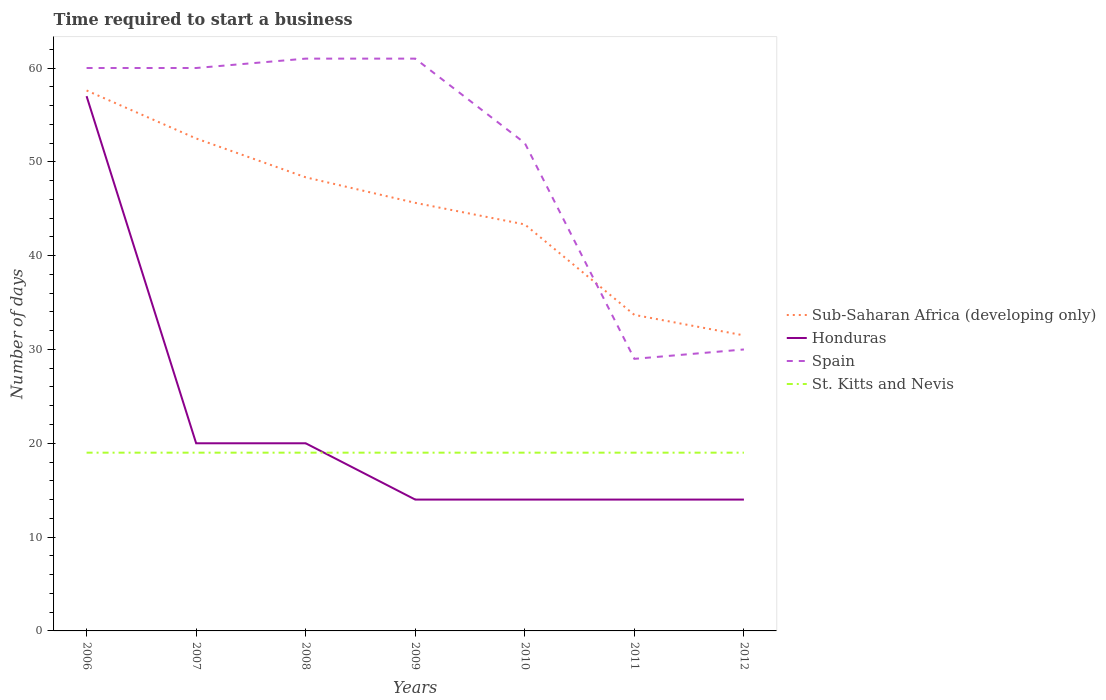How many different coloured lines are there?
Offer a terse response. 4. Does the line corresponding to Sub-Saharan Africa (developing only) intersect with the line corresponding to St. Kitts and Nevis?
Keep it short and to the point. No. Is the number of lines equal to the number of legend labels?
Your answer should be very brief. Yes. Across all years, what is the maximum number of days required to start a business in Sub-Saharan Africa (developing only)?
Offer a very short reply. 31.5. What is the total number of days required to start a business in St. Kitts and Nevis in the graph?
Give a very brief answer. 0. What is the difference between the highest and the second highest number of days required to start a business in Honduras?
Offer a terse response. 43. Is the number of days required to start a business in Sub-Saharan Africa (developing only) strictly greater than the number of days required to start a business in St. Kitts and Nevis over the years?
Ensure brevity in your answer.  No. How many lines are there?
Provide a succinct answer. 4. How many years are there in the graph?
Provide a succinct answer. 7. Are the values on the major ticks of Y-axis written in scientific E-notation?
Offer a terse response. No. Does the graph contain grids?
Your answer should be very brief. No. Where does the legend appear in the graph?
Your answer should be very brief. Center right. How many legend labels are there?
Your response must be concise. 4. What is the title of the graph?
Provide a short and direct response. Time required to start a business. What is the label or title of the Y-axis?
Give a very brief answer. Number of days. What is the Number of days in Sub-Saharan Africa (developing only) in 2006?
Your response must be concise. 57.6. What is the Number of days of Honduras in 2006?
Provide a succinct answer. 57. What is the Number of days in Spain in 2006?
Offer a very short reply. 60. What is the Number of days of Sub-Saharan Africa (developing only) in 2007?
Keep it short and to the point. 52.49. What is the Number of days in Honduras in 2007?
Your answer should be very brief. 20. What is the Number of days of Spain in 2007?
Your answer should be very brief. 60. What is the Number of days in Sub-Saharan Africa (developing only) in 2008?
Your answer should be compact. 48.35. What is the Number of days in Honduras in 2008?
Give a very brief answer. 20. What is the Number of days of St. Kitts and Nevis in 2008?
Ensure brevity in your answer.  19. What is the Number of days in Sub-Saharan Africa (developing only) in 2009?
Offer a terse response. 45.63. What is the Number of days in Honduras in 2009?
Offer a very short reply. 14. What is the Number of days of St. Kitts and Nevis in 2009?
Your response must be concise. 19. What is the Number of days in Sub-Saharan Africa (developing only) in 2010?
Provide a succinct answer. 43.33. What is the Number of days in Honduras in 2010?
Offer a terse response. 14. What is the Number of days of St. Kitts and Nevis in 2010?
Provide a succinct answer. 19. What is the Number of days of Sub-Saharan Africa (developing only) in 2011?
Keep it short and to the point. 33.69. What is the Number of days in Spain in 2011?
Keep it short and to the point. 29. What is the Number of days in Sub-Saharan Africa (developing only) in 2012?
Give a very brief answer. 31.5. What is the Number of days in Honduras in 2012?
Keep it short and to the point. 14. What is the Number of days of St. Kitts and Nevis in 2012?
Your answer should be very brief. 19. Across all years, what is the maximum Number of days in Sub-Saharan Africa (developing only)?
Your answer should be very brief. 57.6. Across all years, what is the maximum Number of days of Honduras?
Keep it short and to the point. 57. Across all years, what is the maximum Number of days of Spain?
Offer a very short reply. 61. Across all years, what is the maximum Number of days in St. Kitts and Nevis?
Your answer should be very brief. 19. Across all years, what is the minimum Number of days of Sub-Saharan Africa (developing only)?
Provide a short and direct response. 31.5. What is the total Number of days in Sub-Saharan Africa (developing only) in the graph?
Offer a terse response. 312.58. What is the total Number of days in Honduras in the graph?
Provide a succinct answer. 153. What is the total Number of days of Spain in the graph?
Offer a very short reply. 353. What is the total Number of days of St. Kitts and Nevis in the graph?
Give a very brief answer. 133. What is the difference between the Number of days in Sub-Saharan Africa (developing only) in 2006 and that in 2007?
Keep it short and to the point. 5.12. What is the difference between the Number of days of Sub-Saharan Africa (developing only) in 2006 and that in 2008?
Provide a short and direct response. 9.26. What is the difference between the Number of days of St. Kitts and Nevis in 2006 and that in 2008?
Provide a succinct answer. 0. What is the difference between the Number of days in Sub-Saharan Africa (developing only) in 2006 and that in 2009?
Your answer should be compact. 11.98. What is the difference between the Number of days in Honduras in 2006 and that in 2009?
Your answer should be compact. 43. What is the difference between the Number of days in Spain in 2006 and that in 2009?
Offer a very short reply. -1. What is the difference between the Number of days in St. Kitts and Nevis in 2006 and that in 2009?
Provide a short and direct response. 0. What is the difference between the Number of days in Sub-Saharan Africa (developing only) in 2006 and that in 2010?
Provide a succinct answer. 14.28. What is the difference between the Number of days in Honduras in 2006 and that in 2010?
Make the answer very short. 43. What is the difference between the Number of days of St. Kitts and Nevis in 2006 and that in 2010?
Your answer should be compact. 0. What is the difference between the Number of days in Sub-Saharan Africa (developing only) in 2006 and that in 2011?
Keep it short and to the point. 23.92. What is the difference between the Number of days in Spain in 2006 and that in 2011?
Provide a short and direct response. 31. What is the difference between the Number of days in Sub-Saharan Africa (developing only) in 2006 and that in 2012?
Offer a very short reply. 26.1. What is the difference between the Number of days of Honduras in 2006 and that in 2012?
Your answer should be compact. 43. What is the difference between the Number of days of Sub-Saharan Africa (developing only) in 2007 and that in 2008?
Give a very brief answer. 4.14. What is the difference between the Number of days in Sub-Saharan Africa (developing only) in 2007 and that in 2009?
Provide a short and direct response. 6.86. What is the difference between the Number of days of Honduras in 2007 and that in 2009?
Offer a terse response. 6. What is the difference between the Number of days in St. Kitts and Nevis in 2007 and that in 2009?
Keep it short and to the point. 0. What is the difference between the Number of days of Sub-Saharan Africa (developing only) in 2007 and that in 2010?
Your answer should be compact. 9.16. What is the difference between the Number of days of Honduras in 2007 and that in 2010?
Keep it short and to the point. 6. What is the difference between the Number of days of Spain in 2007 and that in 2010?
Offer a terse response. 8. What is the difference between the Number of days of Sub-Saharan Africa (developing only) in 2007 and that in 2011?
Give a very brief answer. 18.8. What is the difference between the Number of days of Sub-Saharan Africa (developing only) in 2007 and that in 2012?
Make the answer very short. 20.99. What is the difference between the Number of days in Honduras in 2007 and that in 2012?
Provide a short and direct response. 6. What is the difference between the Number of days in Sub-Saharan Africa (developing only) in 2008 and that in 2009?
Keep it short and to the point. 2.72. What is the difference between the Number of days of Spain in 2008 and that in 2009?
Offer a very short reply. 0. What is the difference between the Number of days in Sub-Saharan Africa (developing only) in 2008 and that in 2010?
Offer a terse response. 5.02. What is the difference between the Number of days of Honduras in 2008 and that in 2010?
Give a very brief answer. 6. What is the difference between the Number of days in St. Kitts and Nevis in 2008 and that in 2010?
Provide a succinct answer. 0. What is the difference between the Number of days of Sub-Saharan Africa (developing only) in 2008 and that in 2011?
Make the answer very short. 14.66. What is the difference between the Number of days of St. Kitts and Nevis in 2008 and that in 2011?
Make the answer very short. 0. What is the difference between the Number of days of Sub-Saharan Africa (developing only) in 2008 and that in 2012?
Ensure brevity in your answer.  16.85. What is the difference between the Number of days in St. Kitts and Nevis in 2008 and that in 2012?
Your answer should be compact. 0. What is the difference between the Number of days of Sub-Saharan Africa (developing only) in 2009 and that in 2010?
Provide a succinct answer. 2.3. What is the difference between the Number of days of Honduras in 2009 and that in 2010?
Offer a terse response. 0. What is the difference between the Number of days of Spain in 2009 and that in 2010?
Offer a terse response. 9. What is the difference between the Number of days in Sub-Saharan Africa (developing only) in 2009 and that in 2011?
Offer a terse response. 11.94. What is the difference between the Number of days of Honduras in 2009 and that in 2011?
Provide a short and direct response. 0. What is the difference between the Number of days in Spain in 2009 and that in 2011?
Your response must be concise. 32. What is the difference between the Number of days in Sub-Saharan Africa (developing only) in 2009 and that in 2012?
Make the answer very short. 14.13. What is the difference between the Number of days in Honduras in 2009 and that in 2012?
Your answer should be compact. 0. What is the difference between the Number of days in St. Kitts and Nevis in 2009 and that in 2012?
Provide a short and direct response. 0. What is the difference between the Number of days of Sub-Saharan Africa (developing only) in 2010 and that in 2011?
Your answer should be very brief. 9.64. What is the difference between the Number of days of Honduras in 2010 and that in 2011?
Give a very brief answer. 0. What is the difference between the Number of days of St. Kitts and Nevis in 2010 and that in 2011?
Ensure brevity in your answer.  0. What is the difference between the Number of days of Sub-Saharan Africa (developing only) in 2010 and that in 2012?
Provide a succinct answer. 11.83. What is the difference between the Number of days in Honduras in 2010 and that in 2012?
Your response must be concise. 0. What is the difference between the Number of days of St. Kitts and Nevis in 2010 and that in 2012?
Your response must be concise. 0. What is the difference between the Number of days of Sub-Saharan Africa (developing only) in 2011 and that in 2012?
Your response must be concise. 2.19. What is the difference between the Number of days of St. Kitts and Nevis in 2011 and that in 2012?
Offer a terse response. 0. What is the difference between the Number of days of Sub-Saharan Africa (developing only) in 2006 and the Number of days of Honduras in 2007?
Provide a succinct answer. 37.6. What is the difference between the Number of days of Sub-Saharan Africa (developing only) in 2006 and the Number of days of Spain in 2007?
Offer a terse response. -2.4. What is the difference between the Number of days in Sub-Saharan Africa (developing only) in 2006 and the Number of days in St. Kitts and Nevis in 2007?
Keep it short and to the point. 38.6. What is the difference between the Number of days of Honduras in 2006 and the Number of days of St. Kitts and Nevis in 2007?
Keep it short and to the point. 38. What is the difference between the Number of days of Spain in 2006 and the Number of days of St. Kitts and Nevis in 2007?
Provide a short and direct response. 41. What is the difference between the Number of days of Sub-Saharan Africa (developing only) in 2006 and the Number of days of Honduras in 2008?
Offer a very short reply. 37.6. What is the difference between the Number of days in Sub-Saharan Africa (developing only) in 2006 and the Number of days in Spain in 2008?
Provide a short and direct response. -3.4. What is the difference between the Number of days in Sub-Saharan Africa (developing only) in 2006 and the Number of days in St. Kitts and Nevis in 2008?
Provide a short and direct response. 38.6. What is the difference between the Number of days of Sub-Saharan Africa (developing only) in 2006 and the Number of days of Honduras in 2009?
Your answer should be very brief. 43.6. What is the difference between the Number of days of Sub-Saharan Africa (developing only) in 2006 and the Number of days of Spain in 2009?
Your response must be concise. -3.4. What is the difference between the Number of days in Sub-Saharan Africa (developing only) in 2006 and the Number of days in St. Kitts and Nevis in 2009?
Give a very brief answer. 38.6. What is the difference between the Number of days in Spain in 2006 and the Number of days in St. Kitts and Nevis in 2009?
Ensure brevity in your answer.  41. What is the difference between the Number of days in Sub-Saharan Africa (developing only) in 2006 and the Number of days in Honduras in 2010?
Make the answer very short. 43.6. What is the difference between the Number of days of Sub-Saharan Africa (developing only) in 2006 and the Number of days of Spain in 2010?
Your answer should be very brief. 5.6. What is the difference between the Number of days of Sub-Saharan Africa (developing only) in 2006 and the Number of days of St. Kitts and Nevis in 2010?
Offer a very short reply. 38.6. What is the difference between the Number of days in Honduras in 2006 and the Number of days in Spain in 2010?
Give a very brief answer. 5. What is the difference between the Number of days in Spain in 2006 and the Number of days in St. Kitts and Nevis in 2010?
Give a very brief answer. 41. What is the difference between the Number of days in Sub-Saharan Africa (developing only) in 2006 and the Number of days in Honduras in 2011?
Ensure brevity in your answer.  43.6. What is the difference between the Number of days of Sub-Saharan Africa (developing only) in 2006 and the Number of days of Spain in 2011?
Your answer should be compact. 28.6. What is the difference between the Number of days in Sub-Saharan Africa (developing only) in 2006 and the Number of days in St. Kitts and Nevis in 2011?
Your response must be concise. 38.6. What is the difference between the Number of days of Spain in 2006 and the Number of days of St. Kitts and Nevis in 2011?
Keep it short and to the point. 41. What is the difference between the Number of days in Sub-Saharan Africa (developing only) in 2006 and the Number of days in Honduras in 2012?
Provide a short and direct response. 43.6. What is the difference between the Number of days of Sub-Saharan Africa (developing only) in 2006 and the Number of days of Spain in 2012?
Ensure brevity in your answer.  27.6. What is the difference between the Number of days in Sub-Saharan Africa (developing only) in 2006 and the Number of days in St. Kitts and Nevis in 2012?
Make the answer very short. 38.6. What is the difference between the Number of days in Honduras in 2006 and the Number of days in Spain in 2012?
Your answer should be very brief. 27. What is the difference between the Number of days of Sub-Saharan Africa (developing only) in 2007 and the Number of days of Honduras in 2008?
Keep it short and to the point. 32.49. What is the difference between the Number of days of Sub-Saharan Africa (developing only) in 2007 and the Number of days of Spain in 2008?
Your answer should be compact. -8.51. What is the difference between the Number of days of Sub-Saharan Africa (developing only) in 2007 and the Number of days of St. Kitts and Nevis in 2008?
Provide a succinct answer. 33.49. What is the difference between the Number of days in Honduras in 2007 and the Number of days in Spain in 2008?
Provide a short and direct response. -41. What is the difference between the Number of days of Honduras in 2007 and the Number of days of St. Kitts and Nevis in 2008?
Make the answer very short. 1. What is the difference between the Number of days in Spain in 2007 and the Number of days in St. Kitts and Nevis in 2008?
Make the answer very short. 41. What is the difference between the Number of days in Sub-Saharan Africa (developing only) in 2007 and the Number of days in Honduras in 2009?
Ensure brevity in your answer.  38.49. What is the difference between the Number of days of Sub-Saharan Africa (developing only) in 2007 and the Number of days of Spain in 2009?
Keep it short and to the point. -8.51. What is the difference between the Number of days in Sub-Saharan Africa (developing only) in 2007 and the Number of days in St. Kitts and Nevis in 2009?
Give a very brief answer. 33.49. What is the difference between the Number of days in Honduras in 2007 and the Number of days in Spain in 2009?
Make the answer very short. -41. What is the difference between the Number of days in Honduras in 2007 and the Number of days in St. Kitts and Nevis in 2009?
Your response must be concise. 1. What is the difference between the Number of days in Spain in 2007 and the Number of days in St. Kitts and Nevis in 2009?
Provide a succinct answer. 41. What is the difference between the Number of days of Sub-Saharan Africa (developing only) in 2007 and the Number of days of Honduras in 2010?
Provide a short and direct response. 38.49. What is the difference between the Number of days of Sub-Saharan Africa (developing only) in 2007 and the Number of days of Spain in 2010?
Offer a terse response. 0.49. What is the difference between the Number of days in Sub-Saharan Africa (developing only) in 2007 and the Number of days in St. Kitts and Nevis in 2010?
Ensure brevity in your answer.  33.49. What is the difference between the Number of days of Honduras in 2007 and the Number of days of Spain in 2010?
Give a very brief answer. -32. What is the difference between the Number of days in Honduras in 2007 and the Number of days in St. Kitts and Nevis in 2010?
Keep it short and to the point. 1. What is the difference between the Number of days in Sub-Saharan Africa (developing only) in 2007 and the Number of days in Honduras in 2011?
Your answer should be very brief. 38.49. What is the difference between the Number of days in Sub-Saharan Africa (developing only) in 2007 and the Number of days in Spain in 2011?
Provide a short and direct response. 23.49. What is the difference between the Number of days of Sub-Saharan Africa (developing only) in 2007 and the Number of days of St. Kitts and Nevis in 2011?
Your answer should be compact. 33.49. What is the difference between the Number of days in Honduras in 2007 and the Number of days in Spain in 2011?
Offer a terse response. -9. What is the difference between the Number of days of Honduras in 2007 and the Number of days of St. Kitts and Nevis in 2011?
Offer a terse response. 1. What is the difference between the Number of days in Spain in 2007 and the Number of days in St. Kitts and Nevis in 2011?
Keep it short and to the point. 41. What is the difference between the Number of days of Sub-Saharan Africa (developing only) in 2007 and the Number of days of Honduras in 2012?
Keep it short and to the point. 38.49. What is the difference between the Number of days in Sub-Saharan Africa (developing only) in 2007 and the Number of days in Spain in 2012?
Provide a short and direct response. 22.49. What is the difference between the Number of days in Sub-Saharan Africa (developing only) in 2007 and the Number of days in St. Kitts and Nevis in 2012?
Your response must be concise. 33.49. What is the difference between the Number of days in Honduras in 2007 and the Number of days in St. Kitts and Nevis in 2012?
Keep it short and to the point. 1. What is the difference between the Number of days of Spain in 2007 and the Number of days of St. Kitts and Nevis in 2012?
Your answer should be very brief. 41. What is the difference between the Number of days in Sub-Saharan Africa (developing only) in 2008 and the Number of days in Honduras in 2009?
Offer a terse response. 34.35. What is the difference between the Number of days of Sub-Saharan Africa (developing only) in 2008 and the Number of days of Spain in 2009?
Your answer should be compact. -12.65. What is the difference between the Number of days in Sub-Saharan Africa (developing only) in 2008 and the Number of days in St. Kitts and Nevis in 2009?
Provide a short and direct response. 29.35. What is the difference between the Number of days in Honduras in 2008 and the Number of days in Spain in 2009?
Your response must be concise. -41. What is the difference between the Number of days in Spain in 2008 and the Number of days in St. Kitts and Nevis in 2009?
Provide a succinct answer. 42. What is the difference between the Number of days of Sub-Saharan Africa (developing only) in 2008 and the Number of days of Honduras in 2010?
Ensure brevity in your answer.  34.35. What is the difference between the Number of days in Sub-Saharan Africa (developing only) in 2008 and the Number of days in Spain in 2010?
Your answer should be very brief. -3.65. What is the difference between the Number of days in Sub-Saharan Africa (developing only) in 2008 and the Number of days in St. Kitts and Nevis in 2010?
Your answer should be compact. 29.35. What is the difference between the Number of days in Honduras in 2008 and the Number of days in Spain in 2010?
Provide a succinct answer. -32. What is the difference between the Number of days in Spain in 2008 and the Number of days in St. Kitts and Nevis in 2010?
Offer a terse response. 42. What is the difference between the Number of days of Sub-Saharan Africa (developing only) in 2008 and the Number of days of Honduras in 2011?
Keep it short and to the point. 34.35. What is the difference between the Number of days in Sub-Saharan Africa (developing only) in 2008 and the Number of days in Spain in 2011?
Give a very brief answer. 19.35. What is the difference between the Number of days of Sub-Saharan Africa (developing only) in 2008 and the Number of days of St. Kitts and Nevis in 2011?
Offer a terse response. 29.35. What is the difference between the Number of days of Honduras in 2008 and the Number of days of Spain in 2011?
Your answer should be compact. -9. What is the difference between the Number of days of Sub-Saharan Africa (developing only) in 2008 and the Number of days of Honduras in 2012?
Your response must be concise. 34.35. What is the difference between the Number of days in Sub-Saharan Africa (developing only) in 2008 and the Number of days in Spain in 2012?
Your response must be concise. 18.35. What is the difference between the Number of days of Sub-Saharan Africa (developing only) in 2008 and the Number of days of St. Kitts and Nevis in 2012?
Make the answer very short. 29.35. What is the difference between the Number of days in Honduras in 2008 and the Number of days in Spain in 2012?
Give a very brief answer. -10. What is the difference between the Number of days in Sub-Saharan Africa (developing only) in 2009 and the Number of days in Honduras in 2010?
Your answer should be very brief. 31.63. What is the difference between the Number of days of Sub-Saharan Africa (developing only) in 2009 and the Number of days of Spain in 2010?
Your answer should be compact. -6.37. What is the difference between the Number of days of Sub-Saharan Africa (developing only) in 2009 and the Number of days of St. Kitts and Nevis in 2010?
Keep it short and to the point. 26.63. What is the difference between the Number of days in Honduras in 2009 and the Number of days in Spain in 2010?
Offer a terse response. -38. What is the difference between the Number of days of Sub-Saharan Africa (developing only) in 2009 and the Number of days of Honduras in 2011?
Your answer should be compact. 31.63. What is the difference between the Number of days of Sub-Saharan Africa (developing only) in 2009 and the Number of days of Spain in 2011?
Ensure brevity in your answer.  16.63. What is the difference between the Number of days of Sub-Saharan Africa (developing only) in 2009 and the Number of days of St. Kitts and Nevis in 2011?
Provide a short and direct response. 26.63. What is the difference between the Number of days of Honduras in 2009 and the Number of days of St. Kitts and Nevis in 2011?
Offer a terse response. -5. What is the difference between the Number of days of Spain in 2009 and the Number of days of St. Kitts and Nevis in 2011?
Make the answer very short. 42. What is the difference between the Number of days in Sub-Saharan Africa (developing only) in 2009 and the Number of days in Honduras in 2012?
Ensure brevity in your answer.  31.63. What is the difference between the Number of days in Sub-Saharan Africa (developing only) in 2009 and the Number of days in Spain in 2012?
Provide a succinct answer. 15.63. What is the difference between the Number of days of Sub-Saharan Africa (developing only) in 2009 and the Number of days of St. Kitts and Nevis in 2012?
Your response must be concise. 26.63. What is the difference between the Number of days of Spain in 2009 and the Number of days of St. Kitts and Nevis in 2012?
Keep it short and to the point. 42. What is the difference between the Number of days in Sub-Saharan Africa (developing only) in 2010 and the Number of days in Honduras in 2011?
Ensure brevity in your answer.  29.33. What is the difference between the Number of days in Sub-Saharan Africa (developing only) in 2010 and the Number of days in Spain in 2011?
Your answer should be compact. 14.33. What is the difference between the Number of days of Sub-Saharan Africa (developing only) in 2010 and the Number of days of St. Kitts and Nevis in 2011?
Provide a succinct answer. 24.33. What is the difference between the Number of days of Spain in 2010 and the Number of days of St. Kitts and Nevis in 2011?
Your answer should be compact. 33. What is the difference between the Number of days of Sub-Saharan Africa (developing only) in 2010 and the Number of days of Honduras in 2012?
Ensure brevity in your answer.  29.33. What is the difference between the Number of days of Sub-Saharan Africa (developing only) in 2010 and the Number of days of Spain in 2012?
Your response must be concise. 13.33. What is the difference between the Number of days of Sub-Saharan Africa (developing only) in 2010 and the Number of days of St. Kitts and Nevis in 2012?
Offer a very short reply. 24.33. What is the difference between the Number of days of Honduras in 2010 and the Number of days of Spain in 2012?
Ensure brevity in your answer.  -16. What is the difference between the Number of days in Sub-Saharan Africa (developing only) in 2011 and the Number of days in Honduras in 2012?
Provide a short and direct response. 19.69. What is the difference between the Number of days in Sub-Saharan Africa (developing only) in 2011 and the Number of days in Spain in 2012?
Ensure brevity in your answer.  3.69. What is the difference between the Number of days in Sub-Saharan Africa (developing only) in 2011 and the Number of days in St. Kitts and Nevis in 2012?
Ensure brevity in your answer.  14.69. What is the average Number of days in Sub-Saharan Africa (developing only) per year?
Ensure brevity in your answer.  44.65. What is the average Number of days in Honduras per year?
Provide a succinct answer. 21.86. What is the average Number of days in Spain per year?
Offer a terse response. 50.43. In the year 2006, what is the difference between the Number of days in Sub-Saharan Africa (developing only) and Number of days in Honduras?
Make the answer very short. 0.6. In the year 2006, what is the difference between the Number of days of Sub-Saharan Africa (developing only) and Number of days of Spain?
Your response must be concise. -2.4. In the year 2006, what is the difference between the Number of days in Sub-Saharan Africa (developing only) and Number of days in St. Kitts and Nevis?
Provide a succinct answer. 38.6. In the year 2006, what is the difference between the Number of days in Honduras and Number of days in Spain?
Your response must be concise. -3. In the year 2006, what is the difference between the Number of days of Honduras and Number of days of St. Kitts and Nevis?
Keep it short and to the point. 38. In the year 2006, what is the difference between the Number of days in Spain and Number of days in St. Kitts and Nevis?
Your answer should be very brief. 41. In the year 2007, what is the difference between the Number of days in Sub-Saharan Africa (developing only) and Number of days in Honduras?
Your response must be concise. 32.49. In the year 2007, what is the difference between the Number of days in Sub-Saharan Africa (developing only) and Number of days in Spain?
Your answer should be very brief. -7.51. In the year 2007, what is the difference between the Number of days in Sub-Saharan Africa (developing only) and Number of days in St. Kitts and Nevis?
Ensure brevity in your answer.  33.49. In the year 2007, what is the difference between the Number of days of Honduras and Number of days of St. Kitts and Nevis?
Give a very brief answer. 1. In the year 2007, what is the difference between the Number of days of Spain and Number of days of St. Kitts and Nevis?
Offer a terse response. 41. In the year 2008, what is the difference between the Number of days of Sub-Saharan Africa (developing only) and Number of days of Honduras?
Provide a succinct answer. 28.35. In the year 2008, what is the difference between the Number of days in Sub-Saharan Africa (developing only) and Number of days in Spain?
Your response must be concise. -12.65. In the year 2008, what is the difference between the Number of days of Sub-Saharan Africa (developing only) and Number of days of St. Kitts and Nevis?
Your response must be concise. 29.35. In the year 2008, what is the difference between the Number of days of Honduras and Number of days of Spain?
Offer a terse response. -41. In the year 2008, what is the difference between the Number of days of Honduras and Number of days of St. Kitts and Nevis?
Your answer should be very brief. 1. In the year 2008, what is the difference between the Number of days in Spain and Number of days in St. Kitts and Nevis?
Your response must be concise. 42. In the year 2009, what is the difference between the Number of days in Sub-Saharan Africa (developing only) and Number of days in Honduras?
Your answer should be very brief. 31.63. In the year 2009, what is the difference between the Number of days in Sub-Saharan Africa (developing only) and Number of days in Spain?
Ensure brevity in your answer.  -15.37. In the year 2009, what is the difference between the Number of days of Sub-Saharan Africa (developing only) and Number of days of St. Kitts and Nevis?
Keep it short and to the point. 26.63. In the year 2009, what is the difference between the Number of days in Honduras and Number of days in Spain?
Provide a succinct answer. -47. In the year 2010, what is the difference between the Number of days of Sub-Saharan Africa (developing only) and Number of days of Honduras?
Offer a terse response. 29.33. In the year 2010, what is the difference between the Number of days in Sub-Saharan Africa (developing only) and Number of days in Spain?
Ensure brevity in your answer.  -8.67. In the year 2010, what is the difference between the Number of days in Sub-Saharan Africa (developing only) and Number of days in St. Kitts and Nevis?
Give a very brief answer. 24.33. In the year 2010, what is the difference between the Number of days in Honduras and Number of days in Spain?
Provide a short and direct response. -38. In the year 2010, what is the difference between the Number of days in Honduras and Number of days in St. Kitts and Nevis?
Keep it short and to the point. -5. In the year 2011, what is the difference between the Number of days in Sub-Saharan Africa (developing only) and Number of days in Honduras?
Give a very brief answer. 19.69. In the year 2011, what is the difference between the Number of days of Sub-Saharan Africa (developing only) and Number of days of Spain?
Provide a short and direct response. 4.69. In the year 2011, what is the difference between the Number of days in Sub-Saharan Africa (developing only) and Number of days in St. Kitts and Nevis?
Ensure brevity in your answer.  14.69. In the year 2011, what is the difference between the Number of days in Honduras and Number of days in Spain?
Your answer should be very brief. -15. In the year 2011, what is the difference between the Number of days of Honduras and Number of days of St. Kitts and Nevis?
Your answer should be very brief. -5. In the year 2011, what is the difference between the Number of days in Spain and Number of days in St. Kitts and Nevis?
Offer a terse response. 10. In the year 2012, what is the difference between the Number of days in Honduras and Number of days in St. Kitts and Nevis?
Ensure brevity in your answer.  -5. What is the ratio of the Number of days in Sub-Saharan Africa (developing only) in 2006 to that in 2007?
Offer a very short reply. 1.1. What is the ratio of the Number of days in Honduras in 2006 to that in 2007?
Provide a succinct answer. 2.85. What is the ratio of the Number of days in Spain in 2006 to that in 2007?
Offer a very short reply. 1. What is the ratio of the Number of days in St. Kitts and Nevis in 2006 to that in 2007?
Offer a very short reply. 1. What is the ratio of the Number of days in Sub-Saharan Africa (developing only) in 2006 to that in 2008?
Your answer should be compact. 1.19. What is the ratio of the Number of days of Honduras in 2006 to that in 2008?
Provide a short and direct response. 2.85. What is the ratio of the Number of days in Spain in 2006 to that in 2008?
Provide a short and direct response. 0.98. What is the ratio of the Number of days of Sub-Saharan Africa (developing only) in 2006 to that in 2009?
Give a very brief answer. 1.26. What is the ratio of the Number of days of Honduras in 2006 to that in 2009?
Offer a terse response. 4.07. What is the ratio of the Number of days of Spain in 2006 to that in 2009?
Your answer should be compact. 0.98. What is the ratio of the Number of days of Sub-Saharan Africa (developing only) in 2006 to that in 2010?
Keep it short and to the point. 1.33. What is the ratio of the Number of days in Honduras in 2006 to that in 2010?
Keep it short and to the point. 4.07. What is the ratio of the Number of days of Spain in 2006 to that in 2010?
Give a very brief answer. 1.15. What is the ratio of the Number of days in Sub-Saharan Africa (developing only) in 2006 to that in 2011?
Offer a terse response. 1.71. What is the ratio of the Number of days of Honduras in 2006 to that in 2011?
Offer a terse response. 4.07. What is the ratio of the Number of days of Spain in 2006 to that in 2011?
Give a very brief answer. 2.07. What is the ratio of the Number of days in St. Kitts and Nevis in 2006 to that in 2011?
Your answer should be compact. 1. What is the ratio of the Number of days in Sub-Saharan Africa (developing only) in 2006 to that in 2012?
Keep it short and to the point. 1.83. What is the ratio of the Number of days of Honduras in 2006 to that in 2012?
Offer a terse response. 4.07. What is the ratio of the Number of days of Spain in 2006 to that in 2012?
Provide a short and direct response. 2. What is the ratio of the Number of days of Sub-Saharan Africa (developing only) in 2007 to that in 2008?
Keep it short and to the point. 1.09. What is the ratio of the Number of days of Spain in 2007 to that in 2008?
Offer a very short reply. 0.98. What is the ratio of the Number of days in Sub-Saharan Africa (developing only) in 2007 to that in 2009?
Provide a short and direct response. 1.15. What is the ratio of the Number of days of Honduras in 2007 to that in 2009?
Offer a very short reply. 1.43. What is the ratio of the Number of days in Spain in 2007 to that in 2009?
Provide a short and direct response. 0.98. What is the ratio of the Number of days of St. Kitts and Nevis in 2007 to that in 2009?
Provide a succinct answer. 1. What is the ratio of the Number of days of Sub-Saharan Africa (developing only) in 2007 to that in 2010?
Your response must be concise. 1.21. What is the ratio of the Number of days in Honduras in 2007 to that in 2010?
Your answer should be very brief. 1.43. What is the ratio of the Number of days of Spain in 2007 to that in 2010?
Give a very brief answer. 1.15. What is the ratio of the Number of days of St. Kitts and Nevis in 2007 to that in 2010?
Your answer should be very brief. 1. What is the ratio of the Number of days of Sub-Saharan Africa (developing only) in 2007 to that in 2011?
Your answer should be very brief. 1.56. What is the ratio of the Number of days in Honduras in 2007 to that in 2011?
Make the answer very short. 1.43. What is the ratio of the Number of days of Spain in 2007 to that in 2011?
Your answer should be compact. 2.07. What is the ratio of the Number of days in St. Kitts and Nevis in 2007 to that in 2011?
Provide a succinct answer. 1. What is the ratio of the Number of days of Sub-Saharan Africa (developing only) in 2007 to that in 2012?
Your answer should be compact. 1.67. What is the ratio of the Number of days of Honduras in 2007 to that in 2012?
Give a very brief answer. 1.43. What is the ratio of the Number of days of Spain in 2007 to that in 2012?
Your answer should be compact. 2. What is the ratio of the Number of days in St. Kitts and Nevis in 2007 to that in 2012?
Your response must be concise. 1. What is the ratio of the Number of days of Sub-Saharan Africa (developing only) in 2008 to that in 2009?
Your answer should be very brief. 1.06. What is the ratio of the Number of days of Honduras in 2008 to that in 2009?
Ensure brevity in your answer.  1.43. What is the ratio of the Number of days of St. Kitts and Nevis in 2008 to that in 2009?
Provide a short and direct response. 1. What is the ratio of the Number of days of Sub-Saharan Africa (developing only) in 2008 to that in 2010?
Give a very brief answer. 1.12. What is the ratio of the Number of days of Honduras in 2008 to that in 2010?
Provide a succinct answer. 1.43. What is the ratio of the Number of days of Spain in 2008 to that in 2010?
Give a very brief answer. 1.17. What is the ratio of the Number of days in Sub-Saharan Africa (developing only) in 2008 to that in 2011?
Your answer should be very brief. 1.44. What is the ratio of the Number of days in Honduras in 2008 to that in 2011?
Provide a short and direct response. 1.43. What is the ratio of the Number of days in Spain in 2008 to that in 2011?
Your response must be concise. 2.1. What is the ratio of the Number of days in Sub-Saharan Africa (developing only) in 2008 to that in 2012?
Keep it short and to the point. 1.53. What is the ratio of the Number of days in Honduras in 2008 to that in 2012?
Provide a succinct answer. 1.43. What is the ratio of the Number of days in Spain in 2008 to that in 2012?
Your answer should be very brief. 2.03. What is the ratio of the Number of days of St. Kitts and Nevis in 2008 to that in 2012?
Keep it short and to the point. 1. What is the ratio of the Number of days in Sub-Saharan Africa (developing only) in 2009 to that in 2010?
Provide a short and direct response. 1.05. What is the ratio of the Number of days in Spain in 2009 to that in 2010?
Your answer should be very brief. 1.17. What is the ratio of the Number of days in Sub-Saharan Africa (developing only) in 2009 to that in 2011?
Provide a succinct answer. 1.35. What is the ratio of the Number of days in Spain in 2009 to that in 2011?
Offer a terse response. 2.1. What is the ratio of the Number of days of St. Kitts and Nevis in 2009 to that in 2011?
Offer a very short reply. 1. What is the ratio of the Number of days in Sub-Saharan Africa (developing only) in 2009 to that in 2012?
Give a very brief answer. 1.45. What is the ratio of the Number of days in Spain in 2009 to that in 2012?
Your response must be concise. 2.03. What is the ratio of the Number of days in St. Kitts and Nevis in 2009 to that in 2012?
Your answer should be compact. 1. What is the ratio of the Number of days in Sub-Saharan Africa (developing only) in 2010 to that in 2011?
Ensure brevity in your answer.  1.29. What is the ratio of the Number of days in Spain in 2010 to that in 2011?
Provide a short and direct response. 1.79. What is the ratio of the Number of days of St. Kitts and Nevis in 2010 to that in 2011?
Offer a very short reply. 1. What is the ratio of the Number of days of Sub-Saharan Africa (developing only) in 2010 to that in 2012?
Ensure brevity in your answer.  1.38. What is the ratio of the Number of days of Spain in 2010 to that in 2012?
Offer a terse response. 1.73. What is the ratio of the Number of days of St. Kitts and Nevis in 2010 to that in 2012?
Ensure brevity in your answer.  1. What is the ratio of the Number of days in Sub-Saharan Africa (developing only) in 2011 to that in 2012?
Make the answer very short. 1.07. What is the ratio of the Number of days in Spain in 2011 to that in 2012?
Make the answer very short. 0.97. What is the difference between the highest and the second highest Number of days in Sub-Saharan Africa (developing only)?
Provide a short and direct response. 5.12. What is the difference between the highest and the second highest Number of days of Spain?
Your response must be concise. 0. What is the difference between the highest and the second highest Number of days of St. Kitts and Nevis?
Your answer should be very brief. 0. What is the difference between the highest and the lowest Number of days in Sub-Saharan Africa (developing only)?
Provide a short and direct response. 26.1. What is the difference between the highest and the lowest Number of days of Honduras?
Offer a very short reply. 43. What is the difference between the highest and the lowest Number of days of St. Kitts and Nevis?
Offer a very short reply. 0. 